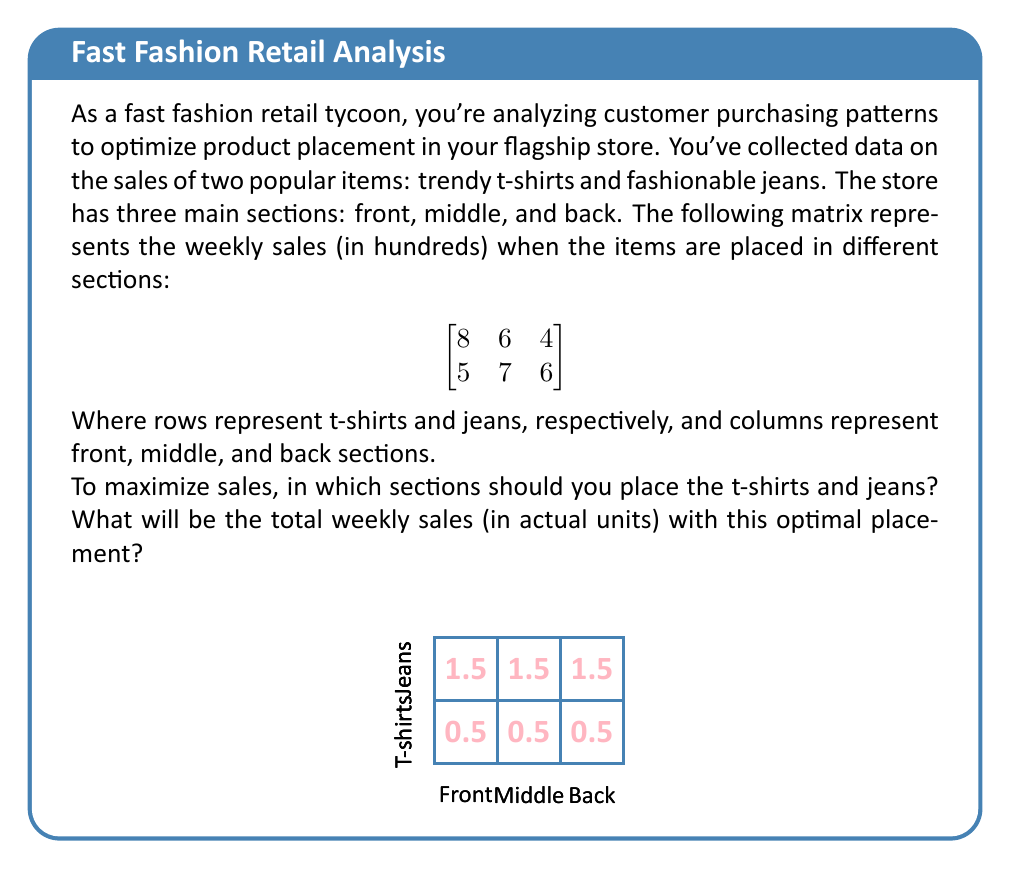Can you answer this question? To solve this optimization problem, we need to find the maximum sum of two elements from the matrix, with the constraint that we can't choose two elements from the same column (as we can't place both items in the same section).

Let's approach this step-by-step:

1) First, let's identify the maximum value for each item:
   T-shirts: 8 (front section)
   Jeans: 7 (middle section)

2) However, we can't choose both of these as they're in different columns. So we need to consider other combinations.

3) Let's systematically check all valid combinations:
   a) T-shirts in front (8) + Jeans in middle (7) = 15
   b) T-shirts in front (8) + Jeans in back (6) = 14
   c) T-shirts in middle (6) + Jeans in front (5) = 11
   d) T-shirts in middle (6) + Jeans in back (6) = 12
   e) T-shirts in back (4) + Jeans in front (5) = 9
   f) T-shirts in back (4) + Jeans in middle (7) = 11

4) The maximum sum is 15, achieved by placing t-shirts in the front section and jeans in the middle section.

5) Remember that the values in the matrix are in hundreds. So the total weekly sales will be 15 * 100 = 1500 units.

Therefore, to maximize sales, t-shirts should be placed in the front section and jeans in the middle section, resulting in total weekly sales of 1500 units.
Answer: T-shirts in front, jeans in middle; 1500 units 